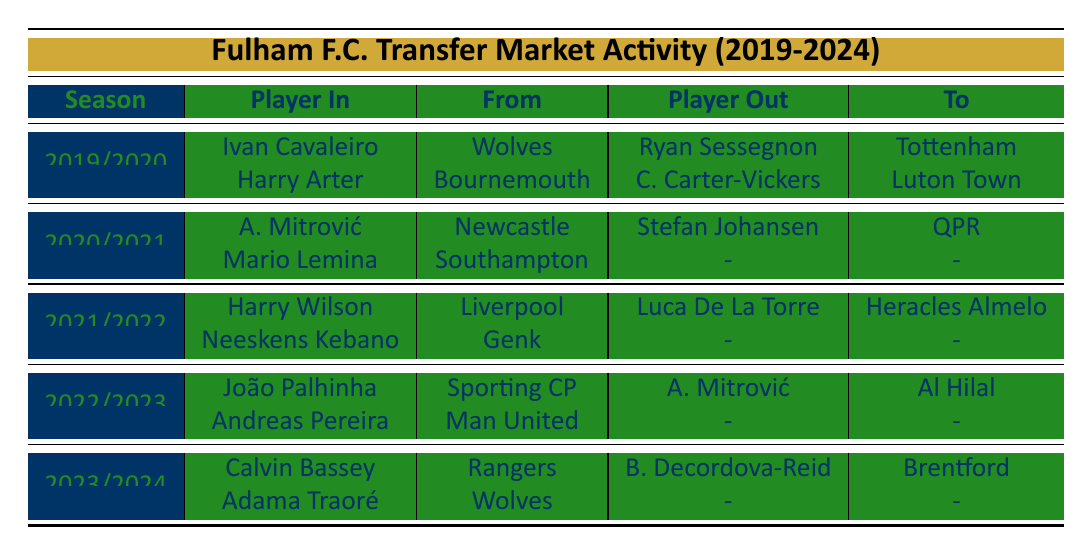What were the outgoing transfers for Fulham F.C. in the 2020/2021 season? In the table, we look at the outgoing transfers for the 2020/2021 season. It shows that the only player transferred out was Stefan Johansen, who went to Queens Park Rangers for a transfer fee of £1 million.
Answer: Stefan Johansen to Queens Park Rangers for £1 million Who was the most expensive player sold by Fulham F.C. during the five seasons listed? We need to compare the transfer fees for outgoing players across all seasons. The highest transfer fee listed is Aleksandar Mitrović, sold for £46 million to Al Hilal in the 2022/2023 season.
Answer: Aleksandar Mitrović for £46 million Did Fulham F.C. loan any players in the 2022/2023 season? In the table, the incoming transfers for the 2022/2023 season do not show any players on loan. Therefore, the answer is no.
Answer: No How many players did Fulham F.C. sign in total over the last five seasons? To find the total number of incoming transfers, we count the players listed for each season: 2 (2019/2020) + 2 (2020/2021) + 2 (2021/2022) + 2 (2022/2023) + 2 (2023/2024) = 10 players.
Answer: 10 players In which season did Fulham F.C. receive a transfer fee for selling a player to Tottenham Hotspur? Checking the table, we find that Ryan Sessegnon was sold to Tottenham Hotspur for £25 million in the 2019/2020 season.
Answer: 2019/2020 Which club did Fulham F.C. sign Calvin Bassey from? In the transfer activity for the 2023/2024 season, Calvin Bassey is noted to have been signed from Rangers.
Answer: Rangers What was the total transfer fee for all outgoing players in the 2021/2022 season? We look at the outgoing transfers: Luca De La Torre was sold for £1 million. There was only one outgoing transfer that season, so the total is £1 million.
Answer: £1 million Is it true that Fulham F.C. had more incoming transfers than outgoing transfers in the 2021/2022 season? The table shows 2 incoming transfers (Harry Wilson and Neeskens Kebano) and 1 outgoing transfer (Luca De La Torre) for that season. Since 2 is greater than 1, the statement is true.
Answer: Yes Which season had the highest total incoming transfer fees? To determine this, we look at the incoming transfers and sum their fees: 2019/2020: £12M + loan (not counted), 2020/2021: £20M + loan (not counted), 2021/2022: £12M + undisclosed (not counted), 2022/2023: £20M + £10M = £30M, and 2023/2024: £18M + loan (not counted) giving £30M for 2022/2023 as the highest.
Answer: 2022/2023 